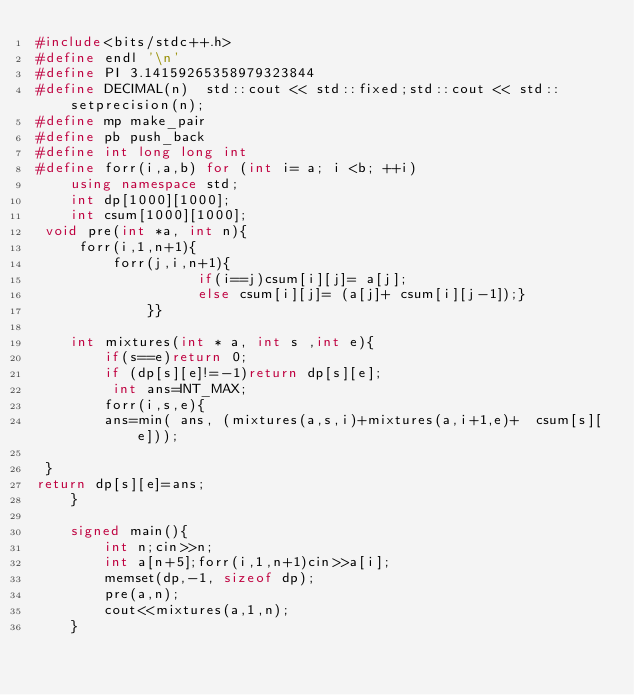Convert code to text. <code><loc_0><loc_0><loc_500><loc_500><_C++_>#include<bits/stdc++.h>
#define endl '\n'
#define PI 3.14159265358979323844
#define DECIMAL(n)  std::cout << std::fixed;std::cout << std::setprecision(n);
#define mp make_pair
#define pb push_back
#define int long long int 
#define forr(i,a,b) for (int i= a; i <b; ++i)
    using namespace std; 
    int dp[1000][1000];
    int csum[1000][1000];
 void pre(int *a, int n){
     forr(i,1,n+1){
         forr(j,i,n+1){
                   if(i==j)csum[i][j]= a[j];
                   else csum[i][j]= (a[j]+ csum[i][j-1]);}
             }}
    
    int mixtures(int * a, int s ,int e){
        if(s==e)return 0;
        if (dp[s][e]!=-1)return dp[s][e]; 
         int ans=INT_MAX;
        forr(i,s,e){
        ans=min( ans, (mixtures(a,s,i)+mixtures(a,i+1,e)+  csum[s][e]));
        
 }
return dp[s][e]=ans;
    }
    
    signed main(){
        int n;cin>>n;
        int a[n+5];forr(i,1,n+1)cin>>a[i];
        memset(dp,-1, sizeof dp);
        pre(a,n);
        cout<<mixtures(a,1,n);
    }</code> 